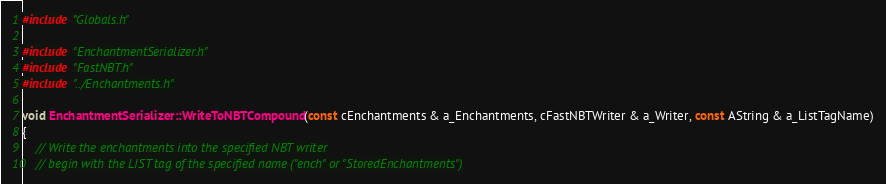<code> <loc_0><loc_0><loc_500><loc_500><_C++_>
#include "Globals.h"

#include "EnchantmentSerializer.h"
#include "FastNBT.h"
#include "../Enchantments.h"

void EnchantmentSerializer::WriteToNBTCompound(const cEnchantments & a_Enchantments, cFastNBTWriter & a_Writer, const AString & a_ListTagName)
{
	// Write the enchantments into the specified NBT writer
	// begin with the LIST tag of the specified name ("ench" or "StoredEnchantments")
</code> 